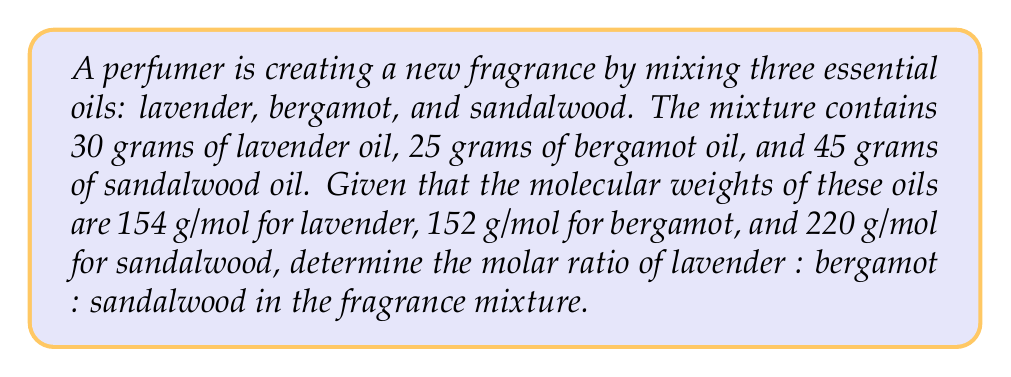Teach me how to tackle this problem. To determine the molar ratio of the components in the fragrance mixture, we need to calculate the number of moles for each essential oil and then express them as a ratio.

1. Calculate the number of moles for each oil:

   Lavender:
   $$\text{moles}_{\text{lavender}} = \frac{\text{mass}}{\text{molecular weight}} = \frac{30 \text{ g}}{154 \text{ g/mol}} = 0.1948 \text{ mol}$$

   Bergamot:
   $$\text{moles}_{\text{bergamot}} = \frac{\text{mass}}{\text{molecular weight}} = \frac{25 \text{ g}}{152 \text{ g/mol}} = 0.1645 \text{ mol}$$

   Sandalwood:
   $$\text{moles}_{\text{sandalwood}} = \frac{\text{mass}}{\text{molecular weight}} = \frac{45 \text{ g}}{220 \text{ g/mol}} = 0.2045 \text{ mol}$$

2. Express the moles as a ratio:
   lavender : bergamot : sandalwood
   0.1948 : 0.1645 : 0.2045

3. Simplify the ratio by dividing all numbers by the smallest value (0.1645):
   $$\frac{0.1948}{0.1645} : \frac{0.1645}{0.1645} : \frac{0.2045}{0.1645}$$
   
   This simplifies to:
   1.18 : 1 : 1.24

4. To get whole numbers, multiply all values by 100:
   118 : 100 : 124

Therefore, the molar ratio of lavender : bergamot : sandalwood in the fragrance mixture is 118 : 100 : 124.
Answer: The molar ratio of lavender : bergamot : sandalwood in the fragrance mixture is 118 : 100 : 124. 